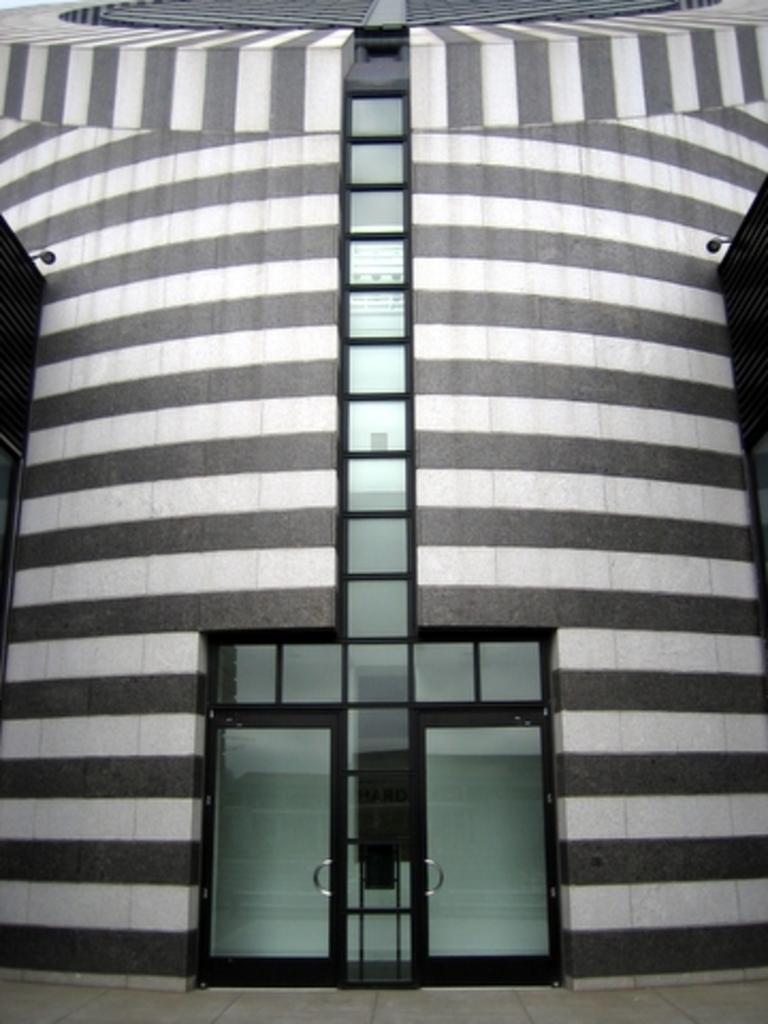Can you describe this image briefly? In the center of the image we can see one building, wall, glass, door, black color objects and a few other objects. 